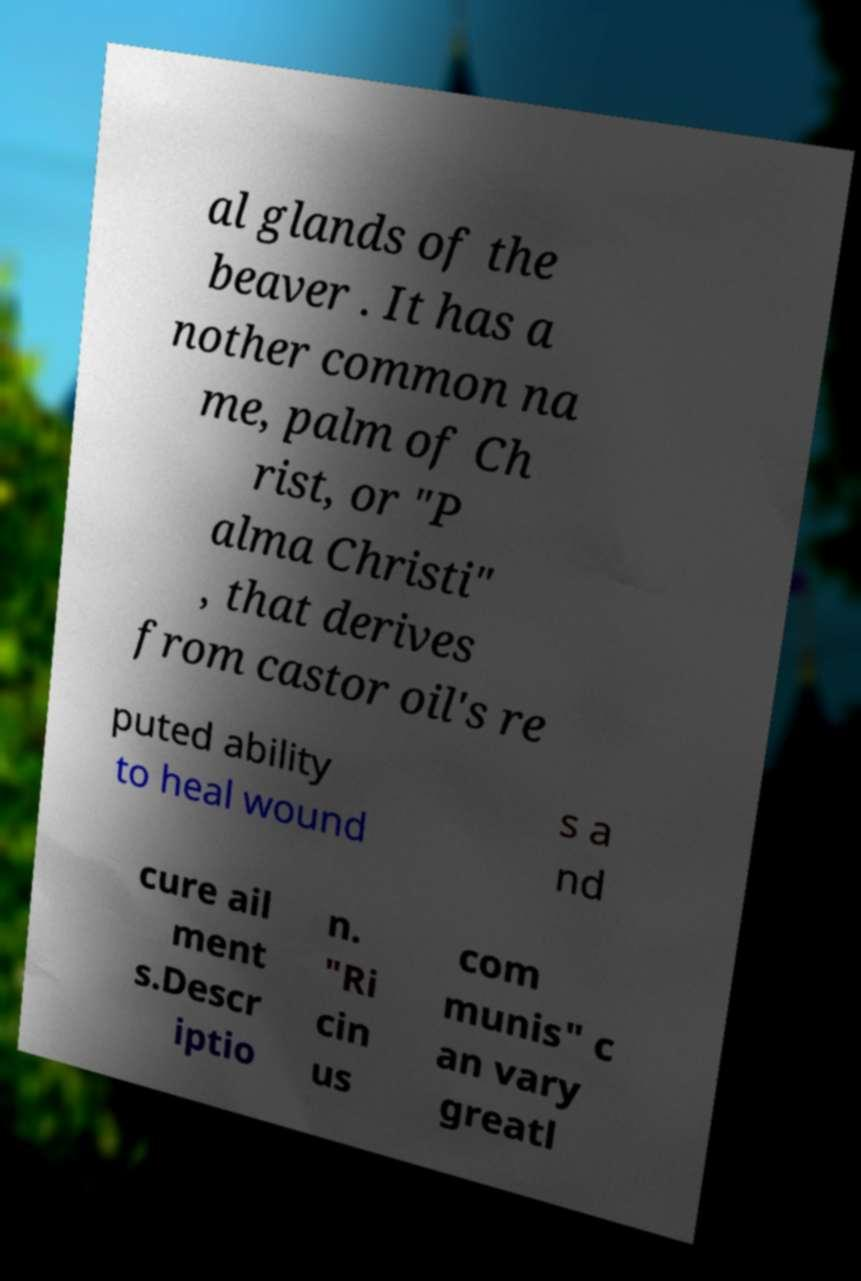For documentation purposes, I need the text within this image transcribed. Could you provide that? al glands of the beaver . It has a nother common na me, palm of Ch rist, or "P alma Christi" , that derives from castor oil's re puted ability to heal wound s a nd cure ail ment s.Descr iptio n. "Ri cin us com munis" c an vary greatl 